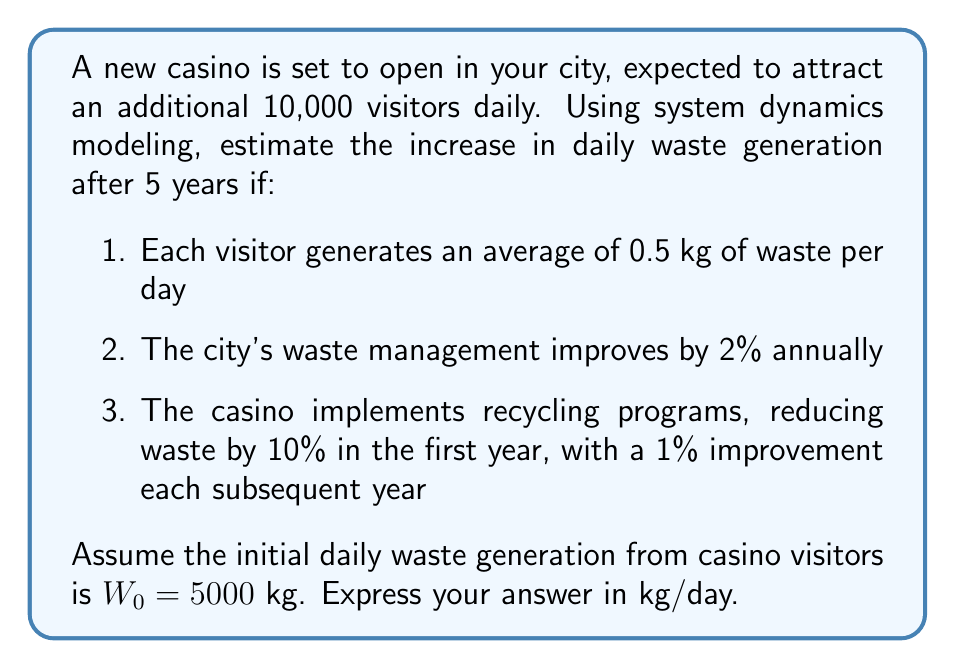What is the answer to this math problem? Let's approach this step-by-step using system dynamics modeling:

1. Initial waste generation:
   $W_0 = 10000 \text{ visitors} \times 0.5 \text{ kg/visitor} = 5000 \text{ kg/day}$

2. Set up the model:
   Let $W_t$ be the waste generation at year $t$.
   $W_t = W_{t-1} \times (1 - \text{waste reduction factor})$

3. Calculate the waste reduction factor for each year:
   Year 1: $10\% + 2\% = 12\%$
   Year 2: $11\% + 2\% = 13\%$
   Year 3: $12\% + 2\% = 14\%$
   Year 4: $13\% + 2\% = 15\%$
   Year 5: $14\% + 2\% = 16\%$

4. Apply the model for each year:
   Year 1: $W_1 = 5000 \times (1 - 0.12) = 4400 \text{ kg/day}$
   Year 2: $W_2 = 4400 \times (1 - 0.13) = 3828 \text{ kg/day}$
   Year 3: $W_3 = 3828 \times (1 - 0.14) = 3292.08 \text{ kg/day}$
   Year 4: $W_4 = 3292.08 \times (1 - 0.15) = 2798.268 \text{ kg/day}$
   Year 5: $W_5 = 2798.268 \times (1 - 0.16) = 2350.54512 \text{ kg/day}$

5. Calculate the increase in daily waste generation:
   $\text{Increase} = W_5 - W_0 = 2350.54512 - 5000 = -2649.45488 \text{ kg/day}$

The negative value indicates a decrease in waste generation due to the implemented measures.
Answer: -2649.45 kg/day 